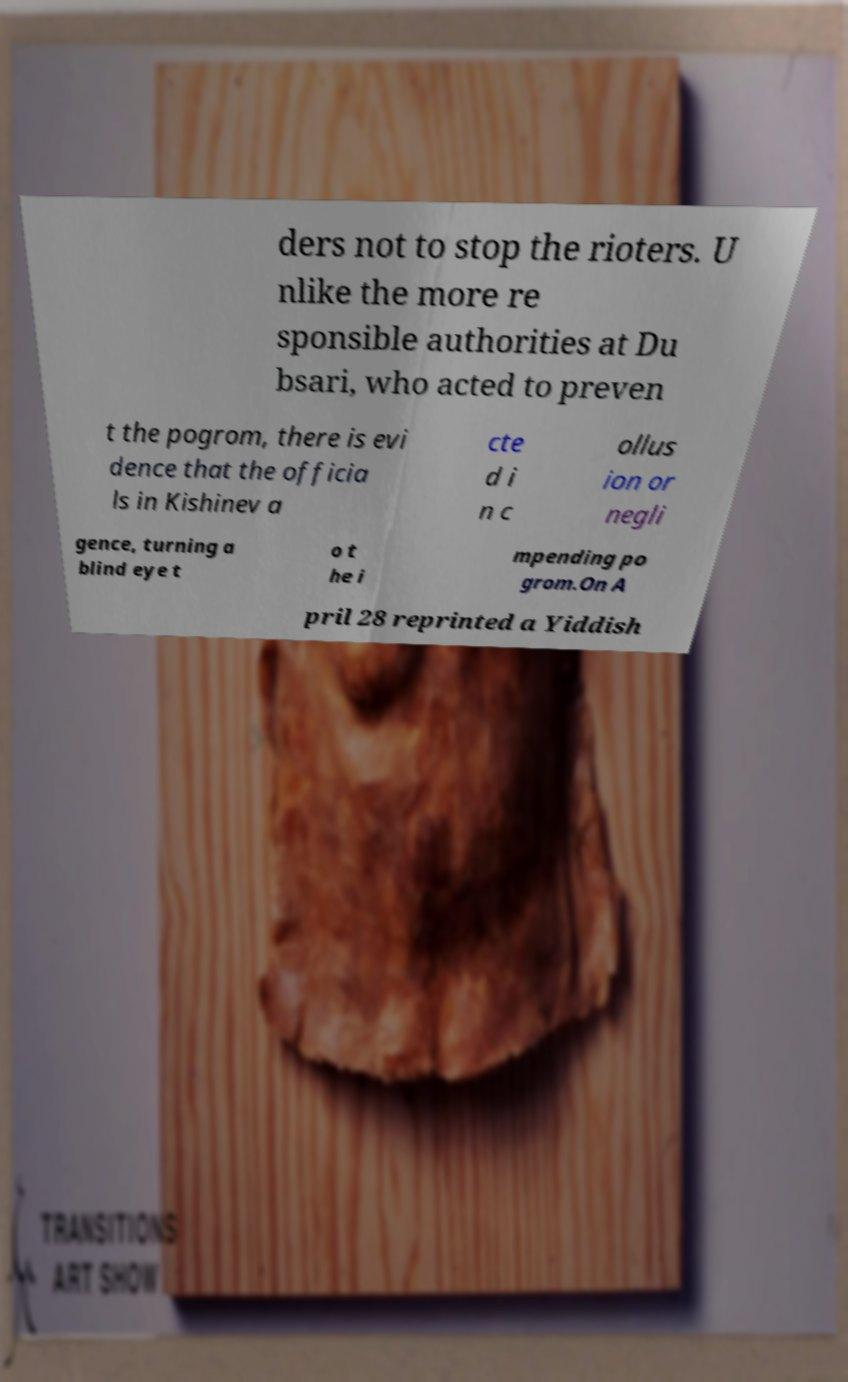I need the written content from this picture converted into text. Can you do that? ders not to stop the rioters. U nlike the more re sponsible authorities at Du bsari, who acted to preven t the pogrom, there is evi dence that the officia ls in Kishinev a cte d i n c ollus ion or negli gence, turning a blind eye t o t he i mpending po grom.On A pril 28 reprinted a Yiddish 